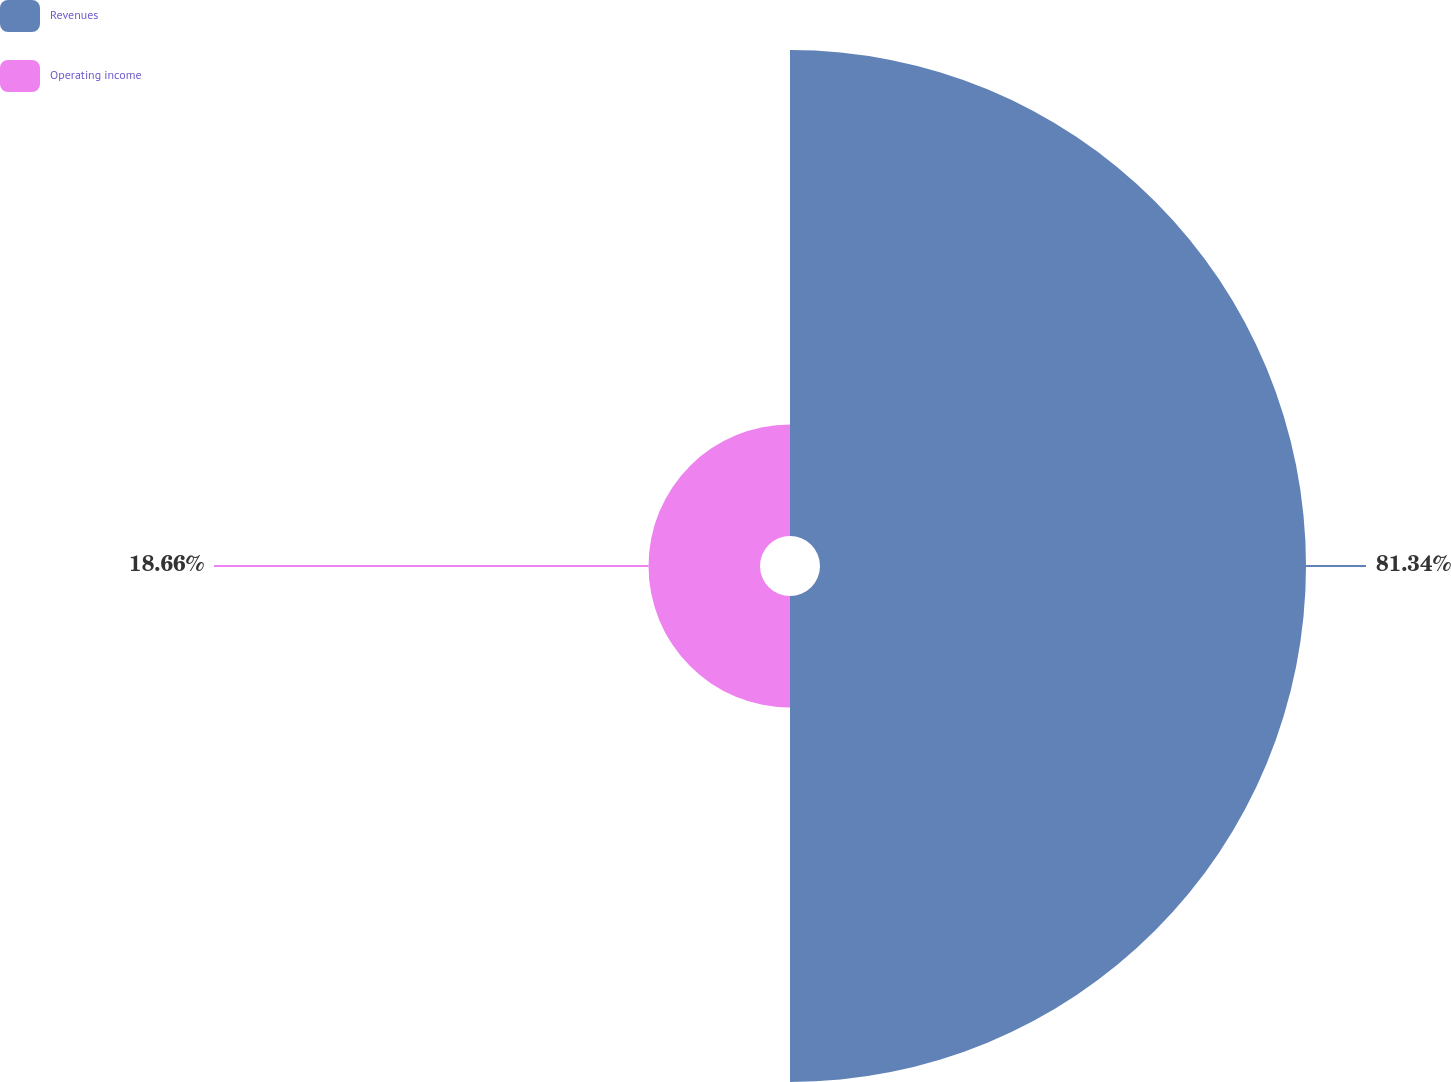<chart> <loc_0><loc_0><loc_500><loc_500><pie_chart><fcel>Revenues<fcel>Operating income<nl><fcel>81.34%<fcel>18.66%<nl></chart> 